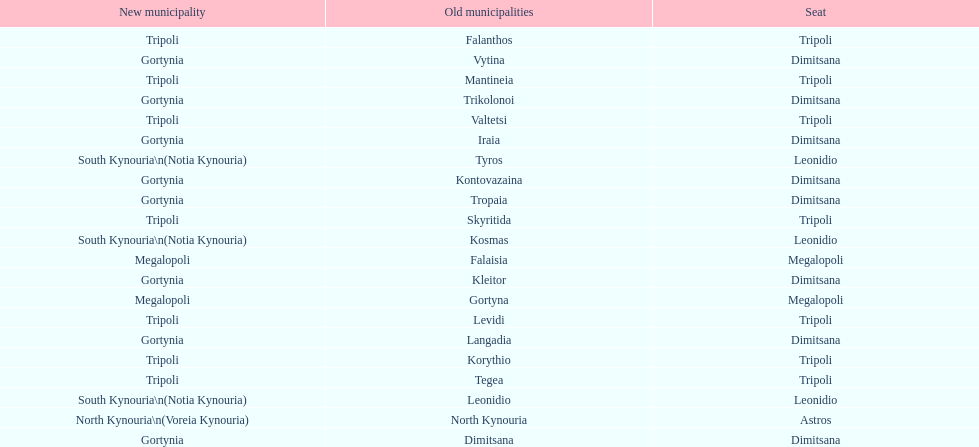How many old municipalities were in tripoli? 8. 